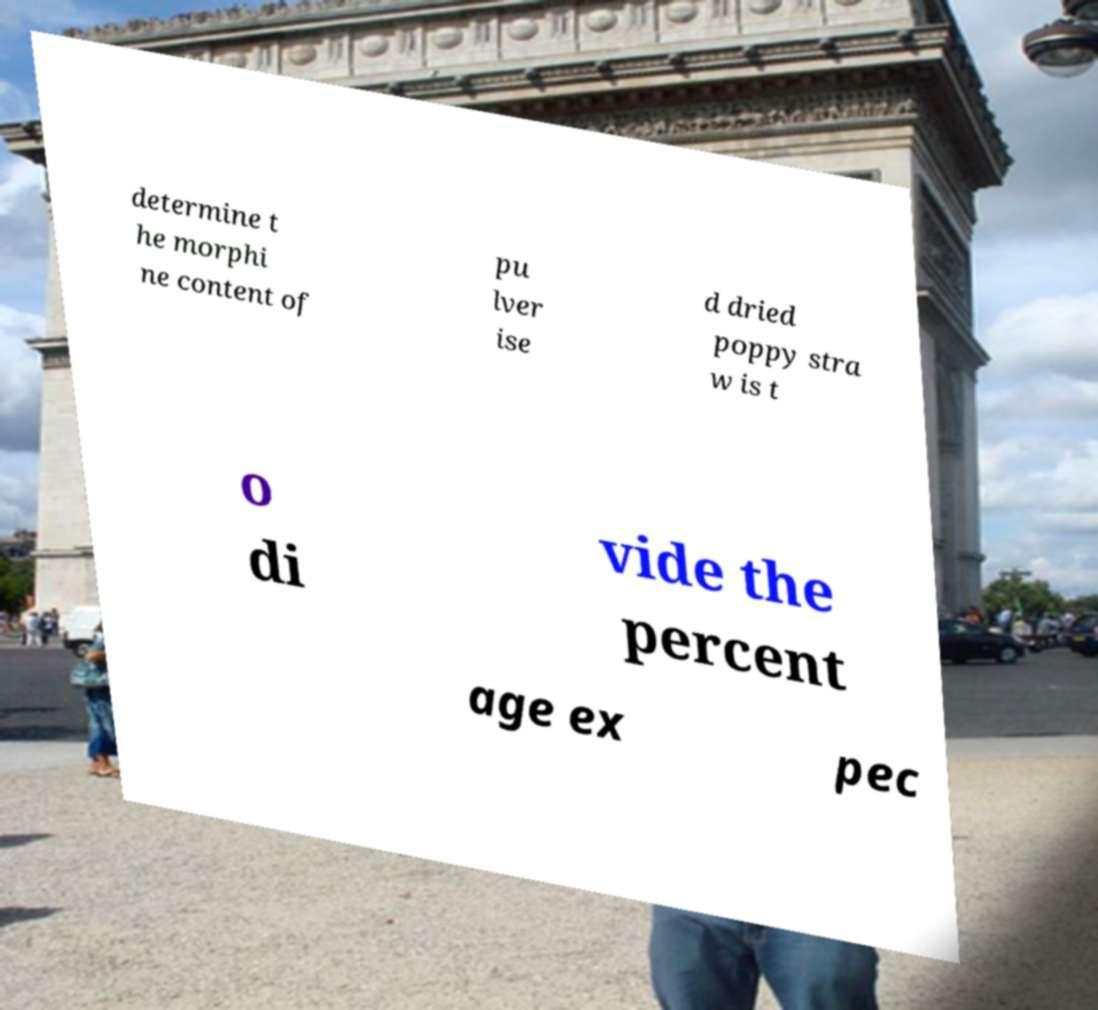Could you extract and type out the text from this image? determine t he morphi ne content of pu lver ise d dried poppy stra w is t o di vide the percent age ex pec 